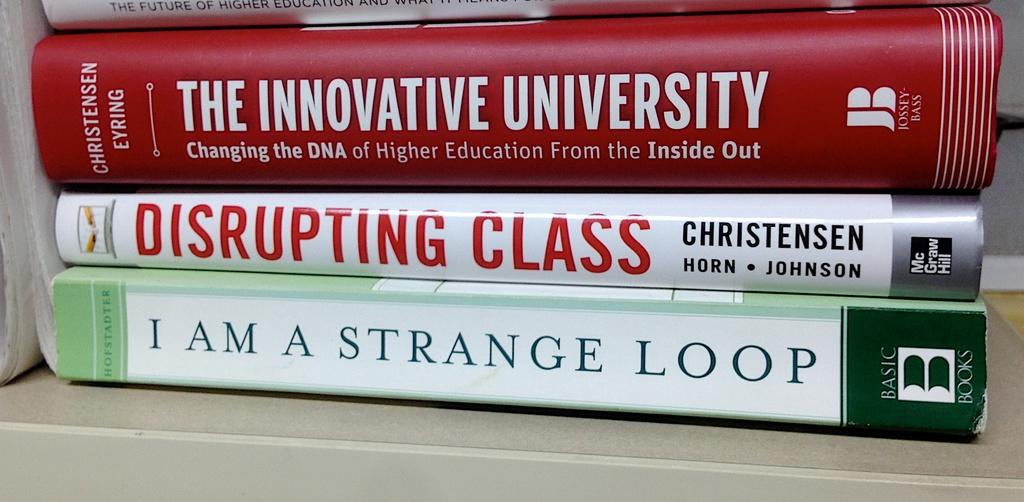What is the title of the red book?
Provide a succinct answer. The innovative university. Who is the author of the red book?
Give a very brief answer. Christensen eyring. 